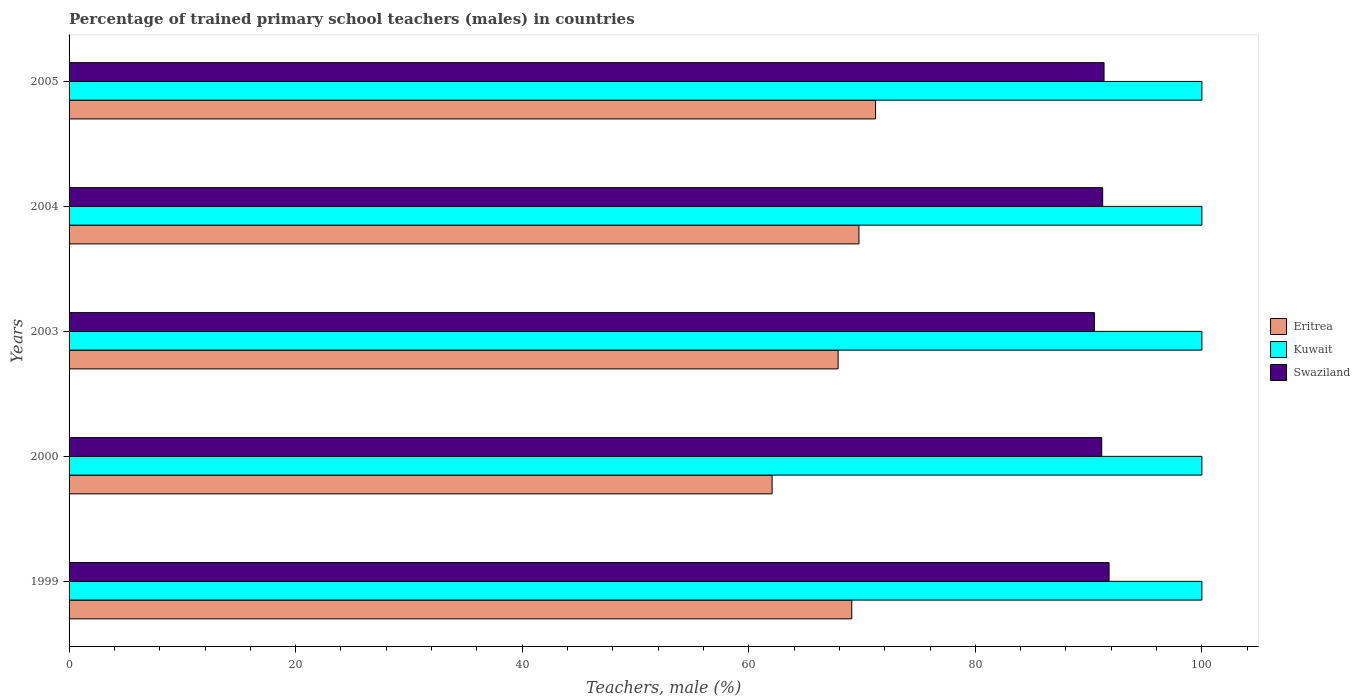How many groups of bars are there?
Offer a very short reply. 5. Are the number of bars per tick equal to the number of legend labels?
Keep it short and to the point. Yes. Are the number of bars on each tick of the Y-axis equal?
Provide a short and direct response. Yes. How many bars are there on the 4th tick from the top?
Make the answer very short. 3. What is the percentage of trained primary school teachers (males) in Swaziland in 1999?
Ensure brevity in your answer.  91.81. Across all years, what is the maximum percentage of trained primary school teachers (males) in Swaziland?
Keep it short and to the point. 91.81. Across all years, what is the minimum percentage of trained primary school teachers (males) in Eritrea?
Keep it short and to the point. 62.06. What is the total percentage of trained primary school teachers (males) in Kuwait in the graph?
Ensure brevity in your answer.  500. What is the difference between the percentage of trained primary school teachers (males) in Eritrea in 2003 and that in 2004?
Provide a succinct answer. -1.84. What is the difference between the percentage of trained primary school teachers (males) in Eritrea in 2000 and the percentage of trained primary school teachers (males) in Swaziland in 2003?
Your answer should be compact. -28.45. What is the average percentage of trained primary school teachers (males) in Swaziland per year?
Your answer should be very brief. 91.22. In the year 2000, what is the difference between the percentage of trained primary school teachers (males) in Kuwait and percentage of trained primary school teachers (males) in Eritrea?
Keep it short and to the point. 37.94. What is the ratio of the percentage of trained primary school teachers (males) in Swaziland in 1999 to that in 2004?
Your response must be concise. 1.01. Is the difference between the percentage of trained primary school teachers (males) in Kuwait in 1999 and 2000 greater than the difference between the percentage of trained primary school teachers (males) in Eritrea in 1999 and 2000?
Provide a short and direct response. No. What is the difference between the highest and the second highest percentage of trained primary school teachers (males) in Swaziland?
Offer a very short reply. 0.44. What is the difference between the highest and the lowest percentage of trained primary school teachers (males) in Eritrea?
Provide a short and direct response. 9.13. Is the sum of the percentage of trained primary school teachers (males) in Eritrea in 2000 and 2003 greater than the maximum percentage of trained primary school teachers (males) in Kuwait across all years?
Your answer should be very brief. Yes. What does the 1st bar from the top in 2004 represents?
Your response must be concise. Swaziland. What does the 2nd bar from the bottom in 1999 represents?
Your answer should be compact. Kuwait. Is it the case that in every year, the sum of the percentage of trained primary school teachers (males) in Eritrea and percentage of trained primary school teachers (males) in Kuwait is greater than the percentage of trained primary school teachers (males) in Swaziland?
Ensure brevity in your answer.  Yes. What is the difference between two consecutive major ticks on the X-axis?
Your answer should be compact. 20. Are the values on the major ticks of X-axis written in scientific E-notation?
Offer a terse response. No. How are the legend labels stacked?
Ensure brevity in your answer.  Vertical. What is the title of the graph?
Provide a succinct answer. Percentage of trained primary school teachers (males) in countries. Does "Argentina" appear as one of the legend labels in the graph?
Your answer should be compact. No. What is the label or title of the X-axis?
Ensure brevity in your answer.  Teachers, male (%). What is the label or title of the Y-axis?
Your answer should be very brief. Years. What is the Teachers, male (%) of Eritrea in 1999?
Keep it short and to the point. 69.09. What is the Teachers, male (%) in Swaziland in 1999?
Offer a terse response. 91.81. What is the Teachers, male (%) in Eritrea in 2000?
Provide a short and direct response. 62.06. What is the Teachers, male (%) of Swaziland in 2000?
Offer a very short reply. 91.16. What is the Teachers, male (%) of Eritrea in 2003?
Ensure brevity in your answer.  67.89. What is the Teachers, male (%) of Swaziland in 2003?
Your answer should be compact. 90.51. What is the Teachers, male (%) in Eritrea in 2004?
Provide a succinct answer. 69.73. What is the Teachers, male (%) of Kuwait in 2004?
Offer a very short reply. 100. What is the Teachers, male (%) in Swaziland in 2004?
Provide a succinct answer. 91.24. What is the Teachers, male (%) of Eritrea in 2005?
Keep it short and to the point. 71.19. What is the Teachers, male (%) of Kuwait in 2005?
Your answer should be compact. 100. What is the Teachers, male (%) of Swaziland in 2005?
Offer a terse response. 91.36. Across all years, what is the maximum Teachers, male (%) in Eritrea?
Keep it short and to the point. 71.19. Across all years, what is the maximum Teachers, male (%) in Kuwait?
Your response must be concise. 100. Across all years, what is the maximum Teachers, male (%) of Swaziland?
Offer a terse response. 91.81. Across all years, what is the minimum Teachers, male (%) in Eritrea?
Offer a terse response. 62.06. Across all years, what is the minimum Teachers, male (%) in Kuwait?
Offer a terse response. 100. Across all years, what is the minimum Teachers, male (%) in Swaziland?
Ensure brevity in your answer.  90.51. What is the total Teachers, male (%) of Eritrea in the graph?
Your response must be concise. 339.96. What is the total Teachers, male (%) in Kuwait in the graph?
Provide a succinct answer. 500. What is the total Teachers, male (%) in Swaziland in the graph?
Your answer should be very brief. 456.08. What is the difference between the Teachers, male (%) of Eritrea in 1999 and that in 2000?
Your response must be concise. 7.03. What is the difference between the Teachers, male (%) of Kuwait in 1999 and that in 2000?
Keep it short and to the point. 0. What is the difference between the Teachers, male (%) in Swaziland in 1999 and that in 2000?
Keep it short and to the point. 0.65. What is the difference between the Teachers, male (%) in Eritrea in 1999 and that in 2003?
Keep it short and to the point. 1.2. What is the difference between the Teachers, male (%) in Kuwait in 1999 and that in 2003?
Give a very brief answer. 0. What is the difference between the Teachers, male (%) in Swaziland in 1999 and that in 2003?
Provide a succinct answer. 1.29. What is the difference between the Teachers, male (%) in Eritrea in 1999 and that in 2004?
Your answer should be very brief. -0.63. What is the difference between the Teachers, male (%) of Swaziland in 1999 and that in 2004?
Keep it short and to the point. 0.56. What is the difference between the Teachers, male (%) in Eritrea in 1999 and that in 2005?
Keep it short and to the point. -2.1. What is the difference between the Teachers, male (%) of Kuwait in 1999 and that in 2005?
Your answer should be very brief. 0. What is the difference between the Teachers, male (%) in Swaziland in 1999 and that in 2005?
Give a very brief answer. 0.44. What is the difference between the Teachers, male (%) of Eritrea in 2000 and that in 2003?
Keep it short and to the point. -5.83. What is the difference between the Teachers, male (%) in Kuwait in 2000 and that in 2003?
Offer a very short reply. 0. What is the difference between the Teachers, male (%) of Swaziland in 2000 and that in 2003?
Provide a short and direct response. 0.65. What is the difference between the Teachers, male (%) in Eritrea in 2000 and that in 2004?
Your answer should be compact. -7.67. What is the difference between the Teachers, male (%) in Swaziland in 2000 and that in 2004?
Keep it short and to the point. -0.08. What is the difference between the Teachers, male (%) in Eritrea in 2000 and that in 2005?
Offer a terse response. -9.13. What is the difference between the Teachers, male (%) in Kuwait in 2000 and that in 2005?
Your answer should be compact. 0. What is the difference between the Teachers, male (%) of Swaziland in 2000 and that in 2005?
Provide a succinct answer. -0.2. What is the difference between the Teachers, male (%) of Eritrea in 2003 and that in 2004?
Provide a short and direct response. -1.84. What is the difference between the Teachers, male (%) in Kuwait in 2003 and that in 2004?
Offer a very short reply. 0. What is the difference between the Teachers, male (%) of Swaziland in 2003 and that in 2004?
Offer a very short reply. -0.73. What is the difference between the Teachers, male (%) in Eritrea in 2003 and that in 2005?
Provide a succinct answer. -3.31. What is the difference between the Teachers, male (%) of Kuwait in 2003 and that in 2005?
Provide a short and direct response. 0. What is the difference between the Teachers, male (%) in Swaziland in 2003 and that in 2005?
Your answer should be very brief. -0.85. What is the difference between the Teachers, male (%) in Eritrea in 2004 and that in 2005?
Offer a very short reply. -1.47. What is the difference between the Teachers, male (%) in Kuwait in 2004 and that in 2005?
Your response must be concise. 0. What is the difference between the Teachers, male (%) of Swaziland in 2004 and that in 2005?
Offer a very short reply. -0.12. What is the difference between the Teachers, male (%) of Eritrea in 1999 and the Teachers, male (%) of Kuwait in 2000?
Offer a very short reply. -30.91. What is the difference between the Teachers, male (%) in Eritrea in 1999 and the Teachers, male (%) in Swaziland in 2000?
Provide a short and direct response. -22.07. What is the difference between the Teachers, male (%) in Kuwait in 1999 and the Teachers, male (%) in Swaziland in 2000?
Provide a succinct answer. 8.84. What is the difference between the Teachers, male (%) of Eritrea in 1999 and the Teachers, male (%) of Kuwait in 2003?
Provide a short and direct response. -30.91. What is the difference between the Teachers, male (%) of Eritrea in 1999 and the Teachers, male (%) of Swaziland in 2003?
Your response must be concise. -21.42. What is the difference between the Teachers, male (%) in Kuwait in 1999 and the Teachers, male (%) in Swaziland in 2003?
Keep it short and to the point. 9.49. What is the difference between the Teachers, male (%) of Eritrea in 1999 and the Teachers, male (%) of Kuwait in 2004?
Your answer should be compact. -30.91. What is the difference between the Teachers, male (%) of Eritrea in 1999 and the Teachers, male (%) of Swaziland in 2004?
Your answer should be compact. -22.15. What is the difference between the Teachers, male (%) of Kuwait in 1999 and the Teachers, male (%) of Swaziland in 2004?
Keep it short and to the point. 8.76. What is the difference between the Teachers, male (%) of Eritrea in 1999 and the Teachers, male (%) of Kuwait in 2005?
Offer a terse response. -30.91. What is the difference between the Teachers, male (%) in Eritrea in 1999 and the Teachers, male (%) in Swaziland in 2005?
Your response must be concise. -22.27. What is the difference between the Teachers, male (%) of Kuwait in 1999 and the Teachers, male (%) of Swaziland in 2005?
Provide a succinct answer. 8.64. What is the difference between the Teachers, male (%) of Eritrea in 2000 and the Teachers, male (%) of Kuwait in 2003?
Ensure brevity in your answer.  -37.94. What is the difference between the Teachers, male (%) in Eritrea in 2000 and the Teachers, male (%) in Swaziland in 2003?
Ensure brevity in your answer.  -28.45. What is the difference between the Teachers, male (%) in Kuwait in 2000 and the Teachers, male (%) in Swaziland in 2003?
Offer a terse response. 9.49. What is the difference between the Teachers, male (%) of Eritrea in 2000 and the Teachers, male (%) of Kuwait in 2004?
Make the answer very short. -37.94. What is the difference between the Teachers, male (%) in Eritrea in 2000 and the Teachers, male (%) in Swaziland in 2004?
Your response must be concise. -29.18. What is the difference between the Teachers, male (%) of Kuwait in 2000 and the Teachers, male (%) of Swaziland in 2004?
Offer a very short reply. 8.76. What is the difference between the Teachers, male (%) of Eritrea in 2000 and the Teachers, male (%) of Kuwait in 2005?
Offer a terse response. -37.94. What is the difference between the Teachers, male (%) of Eritrea in 2000 and the Teachers, male (%) of Swaziland in 2005?
Make the answer very short. -29.3. What is the difference between the Teachers, male (%) in Kuwait in 2000 and the Teachers, male (%) in Swaziland in 2005?
Your answer should be very brief. 8.64. What is the difference between the Teachers, male (%) in Eritrea in 2003 and the Teachers, male (%) in Kuwait in 2004?
Provide a succinct answer. -32.11. What is the difference between the Teachers, male (%) in Eritrea in 2003 and the Teachers, male (%) in Swaziland in 2004?
Your answer should be compact. -23.35. What is the difference between the Teachers, male (%) of Kuwait in 2003 and the Teachers, male (%) of Swaziland in 2004?
Your answer should be very brief. 8.76. What is the difference between the Teachers, male (%) in Eritrea in 2003 and the Teachers, male (%) in Kuwait in 2005?
Give a very brief answer. -32.11. What is the difference between the Teachers, male (%) in Eritrea in 2003 and the Teachers, male (%) in Swaziland in 2005?
Make the answer very short. -23.47. What is the difference between the Teachers, male (%) of Kuwait in 2003 and the Teachers, male (%) of Swaziland in 2005?
Ensure brevity in your answer.  8.64. What is the difference between the Teachers, male (%) in Eritrea in 2004 and the Teachers, male (%) in Kuwait in 2005?
Your response must be concise. -30.27. What is the difference between the Teachers, male (%) in Eritrea in 2004 and the Teachers, male (%) in Swaziland in 2005?
Provide a succinct answer. -21.64. What is the difference between the Teachers, male (%) of Kuwait in 2004 and the Teachers, male (%) of Swaziland in 2005?
Offer a very short reply. 8.64. What is the average Teachers, male (%) of Eritrea per year?
Your answer should be compact. 67.99. What is the average Teachers, male (%) in Swaziland per year?
Give a very brief answer. 91.22. In the year 1999, what is the difference between the Teachers, male (%) of Eritrea and Teachers, male (%) of Kuwait?
Your answer should be compact. -30.91. In the year 1999, what is the difference between the Teachers, male (%) of Eritrea and Teachers, male (%) of Swaziland?
Offer a very short reply. -22.71. In the year 1999, what is the difference between the Teachers, male (%) of Kuwait and Teachers, male (%) of Swaziland?
Make the answer very short. 8.19. In the year 2000, what is the difference between the Teachers, male (%) in Eritrea and Teachers, male (%) in Kuwait?
Provide a succinct answer. -37.94. In the year 2000, what is the difference between the Teachers, male (%) in Eritrea and Teachers, male (%) in Swaziland?
Provide a short and direct response. -29.1. In the year 2000, what is the difference between the Teachers, male (%) in Kuwait and Teachers, male (%) in Swaziland?
Keep it short and to the point. 8.84. In the year 2003, what is the difference between the Teachers, male (%) of Eritrea and Teachers, male (%) of Kuwait?
Provide a succinct answer. -32.11. In the year 2003, what is the difference between the Teachers, male (%) in Eritrea and Teachers, male (%) in Swaziland?
Provide a short and direct response. -22.62. In the year 2003, what is the difference between the Teachers, male (%) of Kuwait and Teachers, male (%) of Swaziland?
Provide a succinct answer. 9.49. In the year 2004, what is the difference between the Teachers, male (%) of Eritrea and Teachers, male (%) of Kuwait?
Your answer should be very brief. -30.27. In the year 2004, what is the difference between the Teachers, male (%) in Eritrea and Teachers, male (%) in Swaziland?
Offer a very short reply. -21.52. In the year 2004, what is the difference between the Teachers, male (%) of Kuwait and Teachers, male (%) of Swaziland?
Your answer should be compact. 8.76. In the year 2005, what is the difference between the Teachers, male (%) of Eritrea and Teachers, male (%) of Kuwait?
Offer a terse response. -28.81. In the year 2005, what is the difference between the Teachers, male (%) of Eritrea and Teachers, male (%) of Swaziland?
Keep it short and to the point. -20.17. In the year 2005, what is the difference between the Teachers, male (%) of Kuwait and Teachers, male (%) of Swaziland?
Keep it short and to the point. 8.64. What is the ratio of the Teachers, male (%) of Eritrea in 1999 to that in 2000?
Your answer should be very brief. 1.11. What is the ratio of the Teachers, male (%) in Swaziland in 1999 to that in 2000?
Keep it short and to the point. 1.01. What is the ratio of the Teachers, male (%) in Eritrea in 1999 to that in 2003?
Ensure brevity in your answer.  1.02. What is the ratio of the Teachers, male (%) of Swaziland in 1999 to that in 2003?
Give a very brief answer. 1.01. What is the ratio of the Teachers, male (%) of Eritrea in 1999 to that in 2004?
Your response must be concise. 0.99. What is the ratio of the Teachers, male (%) of Swaziland in 1999 to that in 2004?
Offer a terse response. 1.01. What is the ratio of the Teachers, male (%) in Eritrea in 1999 to that in 2005?
Provide a succinct answer. 0.97. What is the ratio of the Teachers, male (%) in Kuwait in 1999 to that in 2005?
Your answer should be very brief. 1. What is the ratio of the Teachers, male (%) in Swaziland in 1999 to that in 2005?
Your answer should be very brief. 1. What is the ratio of the Teachers, male (%) of Eritrea in 2000 to that in 2003?
Ensure brevity in your answer.  0.91. What is the ratio of the Teachers, male (%) in Kuwait in 2000 to that in 2003?
Your answer should be compact. 1. What is the ratio of the Teachers, male (%) in Swaziland in 2000 to that in 2003?
Give a very brief answer. 1.01. What is the ratio of the Teachers, male (%) in Eritrea in 2000 to that in 2004?
Your answer should be compact. 0.89. What is the ratio of the Teachers, male (%) of Swaziland in 2000 to that in 2004?
Your answer should be compact. 1. What is the ratio of the Teachers, male (%) in Eritrea in 2000 to that in 2005?
Your answer should be very brief. 0.87. What is the ratio of the Teachers, male (%) in Eritrea in 2003 to that in 2004?
Offer a very short reply. 0.97. What is the ratio of the Teachers, male (%) of Kuwait in 2003 to that in 2004?
Offer a terse response. 1. What is the ratio of the Teachers, male (%) of Eritrea in 2003 to that in 2005?
Your response must be concise. 0.95. What is the ratio of the Teachers, male (%) in Swaziland in 2003 to that in 2005?
Provide a short and direct response. 0.99. What is the ratio of the Teachers, male (%) of Eritrea in 2004 to that in 2005?
Make the answer very short. 0.98. What is the ratio of the Teachers, male (%) of Kuwait in 2004 to that in 2005?
Provide a succinct answer. 1. What is the difference between the highest and the second highest Teachers, male (%) of Eritrea?
Your answer should be very brief. 1.47. What is the difference between the highest and the second highest Teachers, male (%) of Kuwait?
Ensure brevity in your answer.  0. What is the difference between the highest and the second highest Teachers, male (%) of Swaziland?
Provide a succinct answer. 0.44. What is the difference between the highest and the lowest Teachers, male (%) of Eritrea?
Give a very brief answer. 9.13. What is the difference between the highest and the lowest Teachers, male (%) of Kuwait?
Provide a succinct answer. 0. What is the difference between the highest and the lowest Teachers, male (%) in Swaziland?
Offer a very short reply. 1.29. 